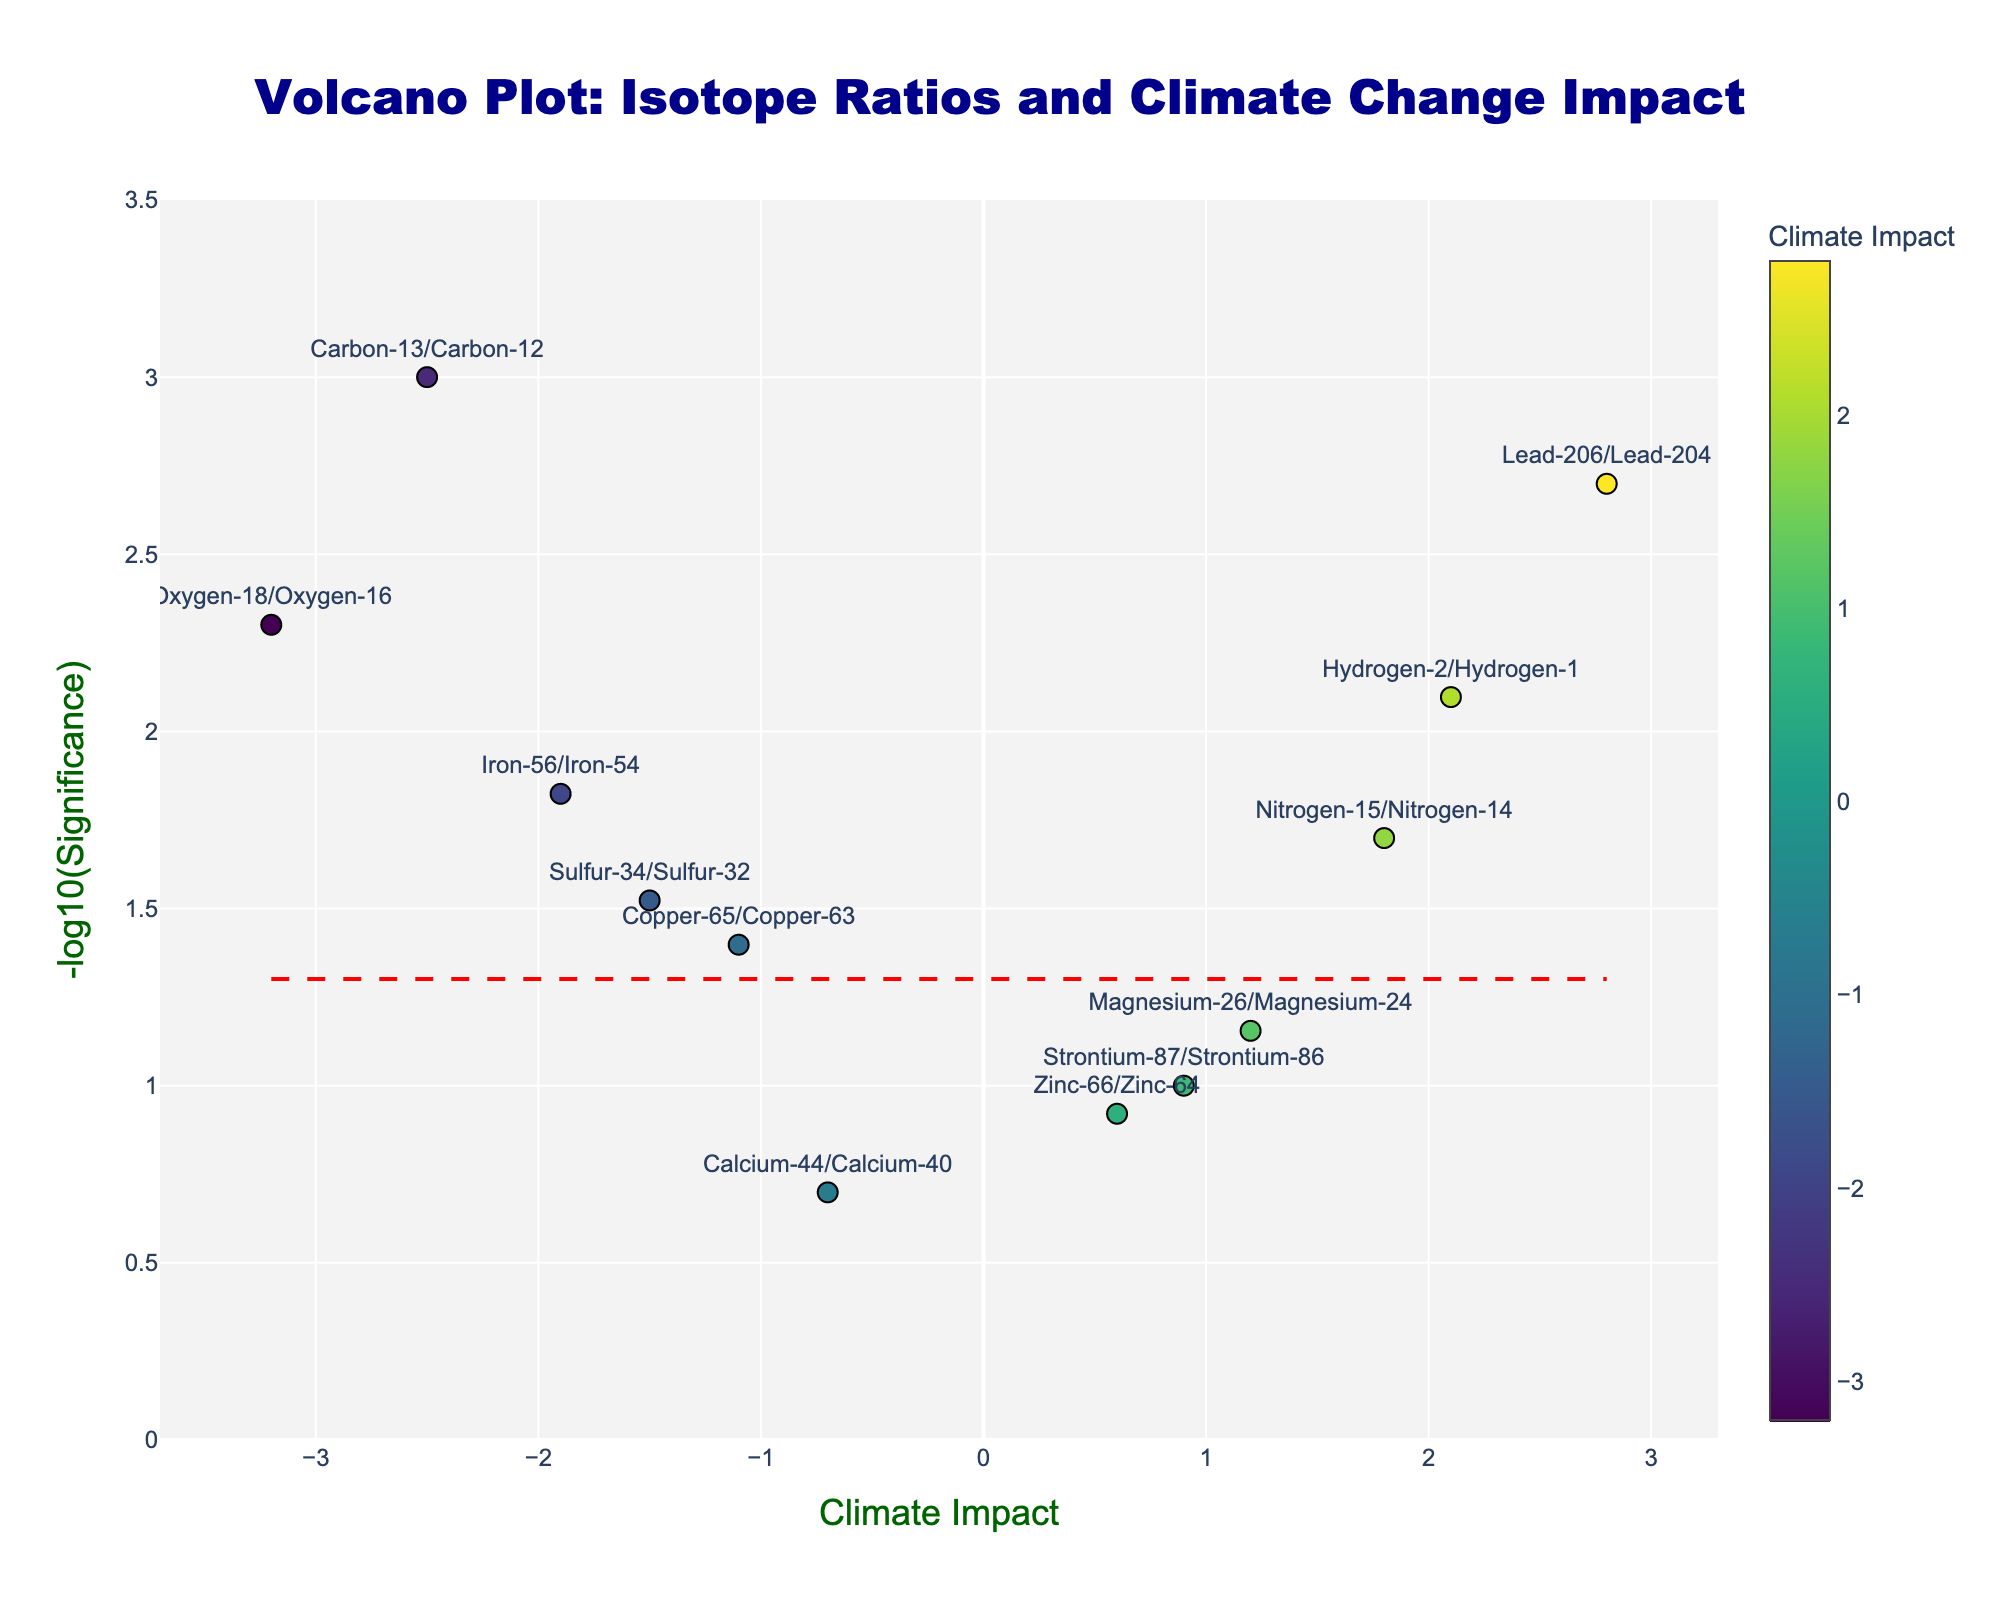How many isotope ratios are plotted on the volcano plot? By counting the individual markers on the figure, where each marker represents a unique isotope ratio, we can determine the total number of isotope ratios.
Answer: 12 What is the title of the plot? The title is located at the top of the figure and it provides a concise description of the plot's purpose.
Answer: "Volcano Plot: Isotope Ratios and Climate Change Impact" Which isotope ratio has the highest climate impact? By locating the marker on the x-axis with the highest positive value, we identify the isotope ratio with the highest climate impact.
Answer: Lead-206/Lead-204 Which isotope ratio shows the least significant impact on climate change? Find the marker on the y-axis that has the lowest value of -log10(significance), as this corresponds to the least significant impact.
Answer: Calcium-44/Calcium-40 Of all the isotope ratios with positive climate impact, which one shows the highest significance? Locate the marker with a positive value on the x-axis and the highest value on the y-axis. Compare these markers to find the highest significance.
Answer: Lead-206/Lead-204 What does the y-axis represent in the plot? The label on the y-axis indicates it represents the -log10 of the significance values of the isotope ratios.
Answer: "-log10(Significance)" How many isotope ratios show a negative climate impact? Count the markers located on the left side of the origin (negative values on the x-axis) to determine how many show a negative climate impact.
Answer: 7 How does the plot indicate the strength of the climate impact associated with each isotope ratio? The x-axis values indicate the climate impact, and these markers are color-coded using a scale that enhances visual differentiation.
Answer: The x-axis values and color coding Which isotope ratio is nearest to the significance threshold line? Identify the marker nearest to the dashed red line, which represents the significance threshold in the plot.
Answer: Copper-65/Copper-63 Are there more isotope ratios with significant climate impact (p < 0.05) or not significant (p >= 0.05)? Determine which segments on the plot are above or below the dashed red line, and count the respective markers.
Answer: More significant (p < 0.05) 